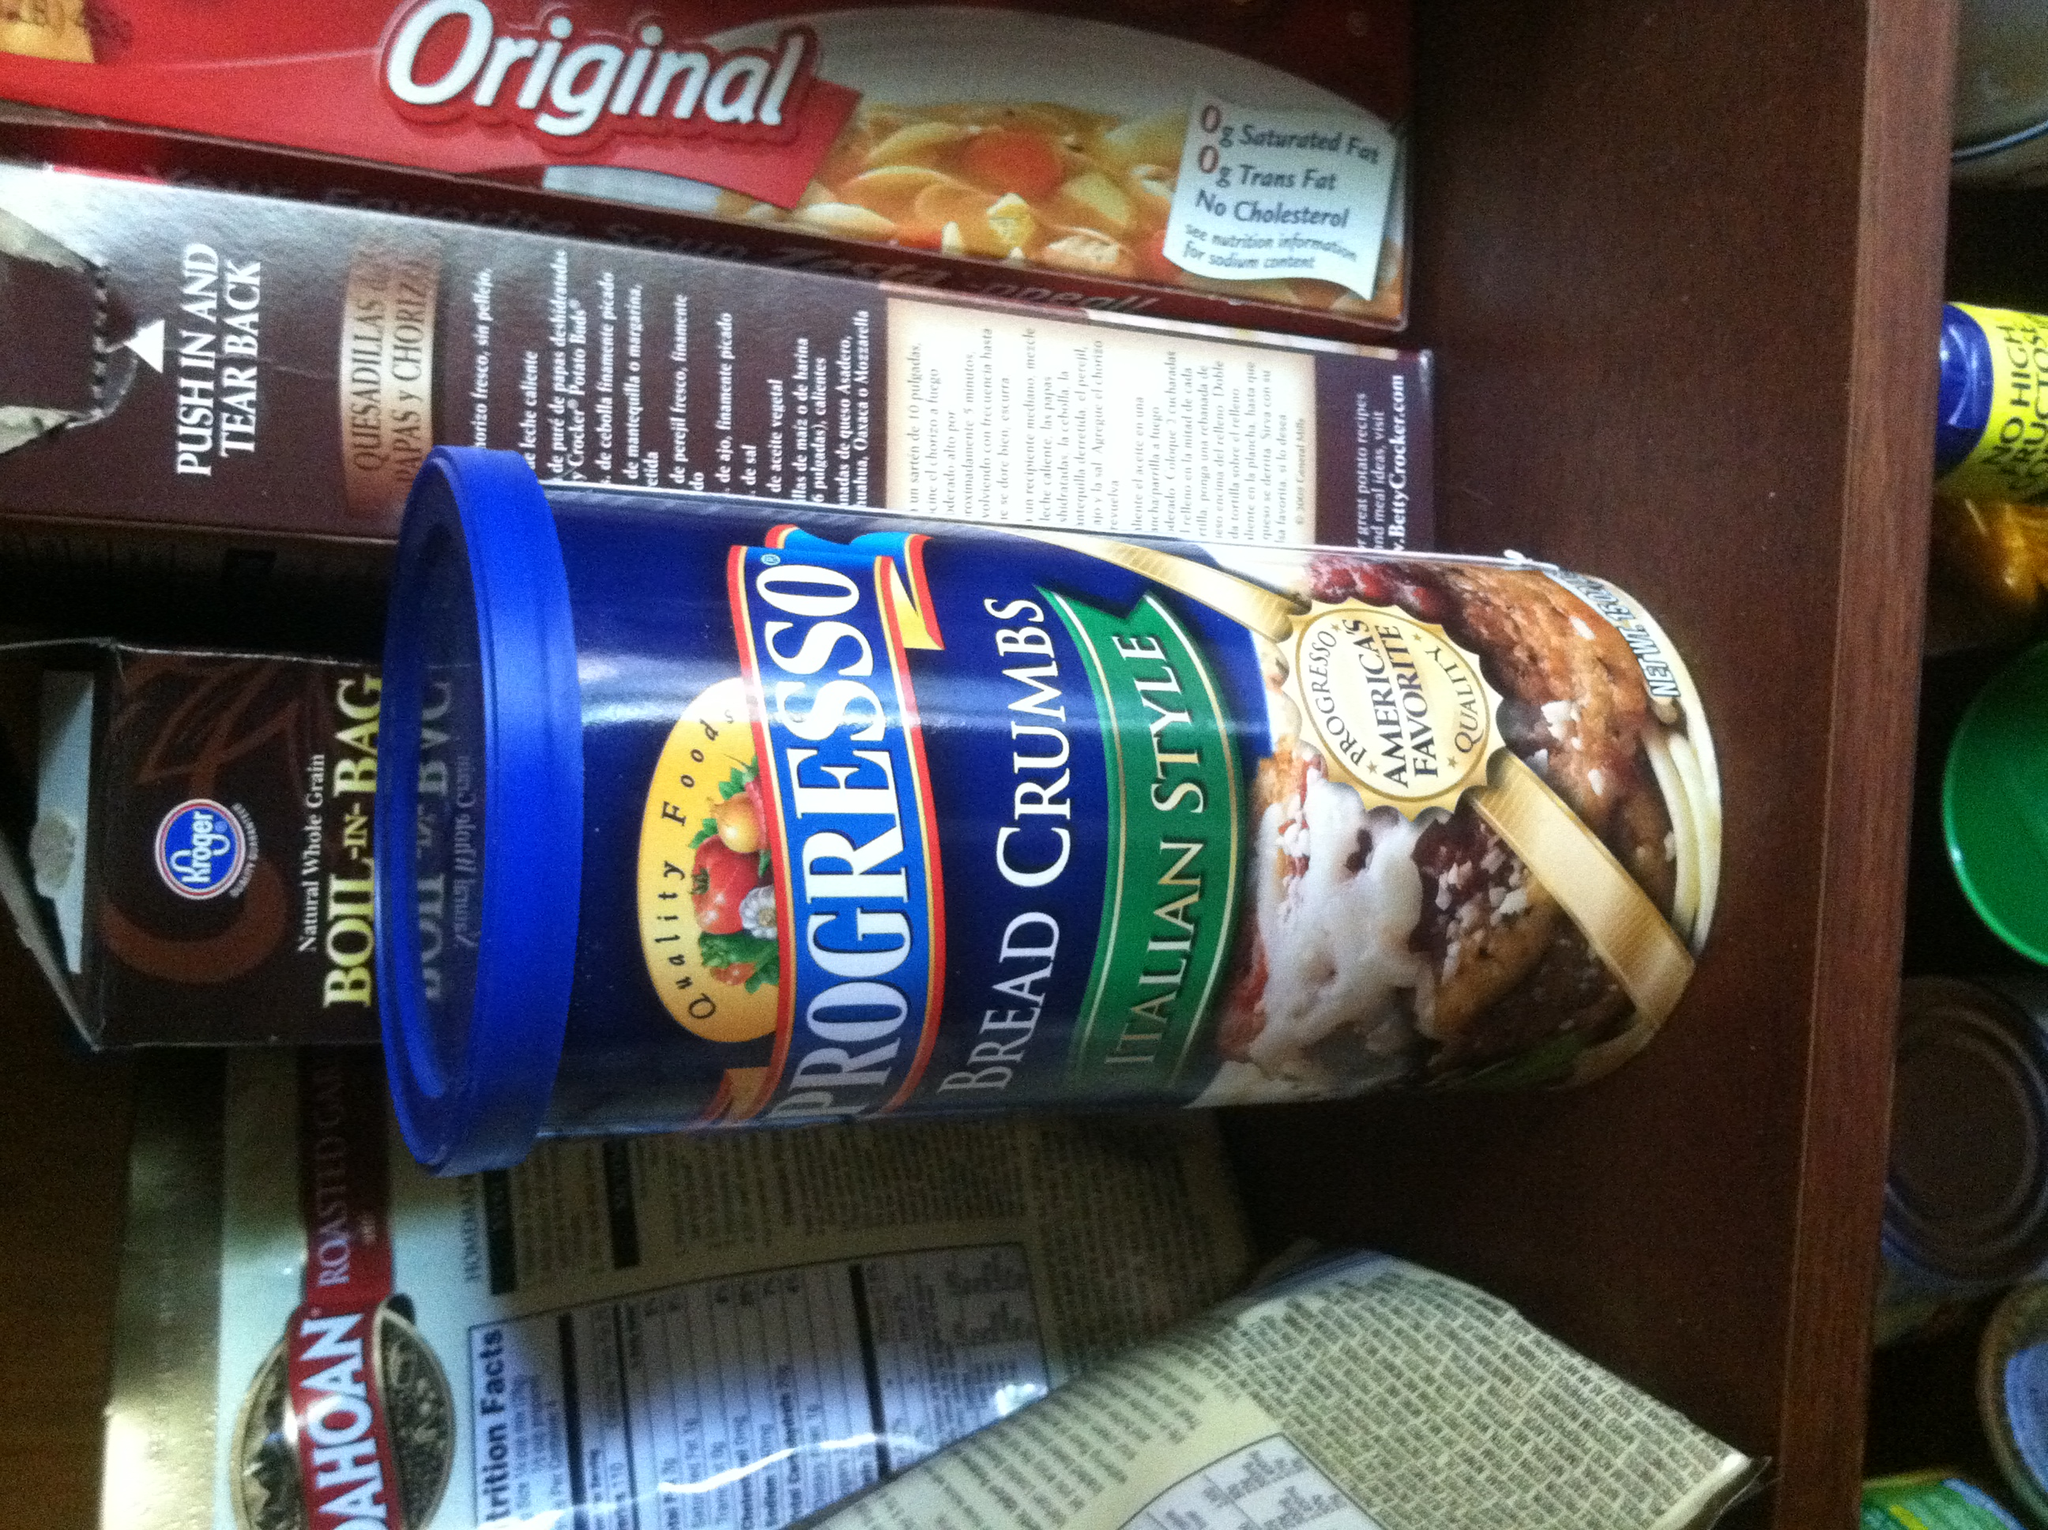What is it? This is a container of Progresso Italian Style Bread Crumbs. Bread crumbs are often used in cooking for breading or crumbing foods, topping casseroles, or incorporating into meatballs and meatloaf to improve texture. 